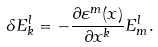Convert formula to latex. <formula><loc_0><loc_0><loc_500><loc_500>\delta E _ { k } ^ { l } = - \frac { \partial \varepsilon ^ { m } ( x ) } { \partial x ^ { k } } E _ { m } ^ { l } .</formula> 